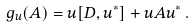<formula> <loc_0><loc_0><loc_500><loc_500>\ g _ { u } ( A ) = u [ D , u ^ { * } ] + u A u ^ { * } \, .</formula> 